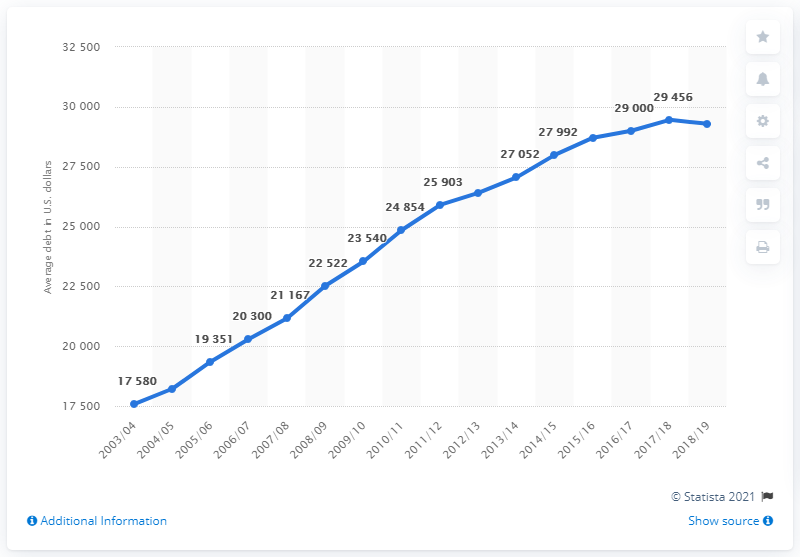Mention a couple of crucial points in this snapshot. In the United States, the average amount of debt that university graduates had ended in the academic year 2018/2019. In the academic year 2003/04, the average amount of debt that university graduates had in the United States was. 